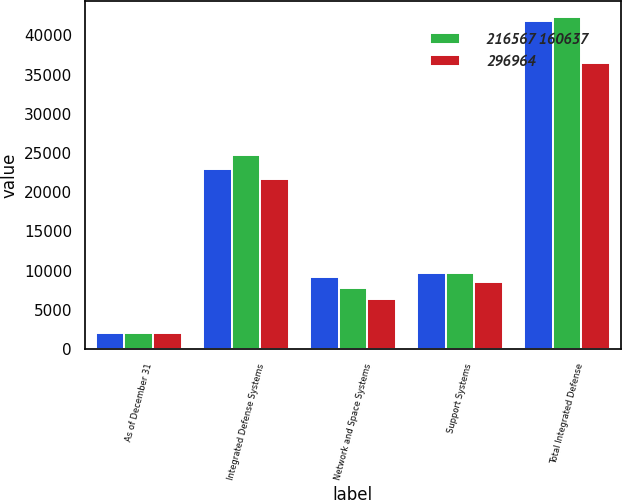Convert chart. <chart><loc_0><loc_0><loc_500><loc_500><stacked_bar_chart><ecel><fcel>As of December 31<fcel>Integrated Defense Systems<fcel>Network and Space Systems<fcel>Support Systems<fcel>Total Integrated Defense<nl><fcel>nan<fcel>2007<fcel>22957<fcel>9167<fcel>9664<fcel>41788<nl><fcel>216567 160637<fcel>2006<fcel>24739<fcel>7838<fcel>9714<fcel>42291<nl><fcel>296964<fcel>2005<fcel>21630<fcel>6324<fcel>8551<fcel>36505<nl></chart> 